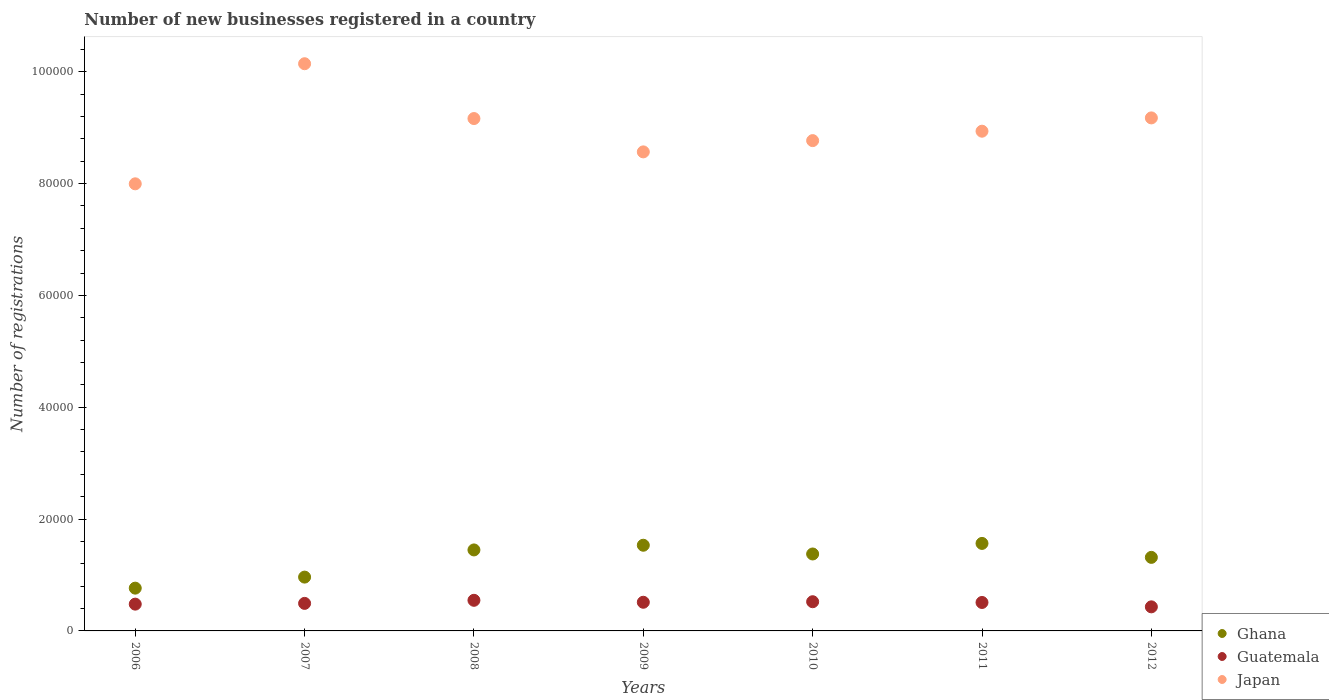What is the number of new businesses registered in Japan in 2010?
Your answer should be compact. 8.77e+04. Across all years, what is the maximum number of new businesses registered in Guatemala?
Ensure brevity in your answer.  5476. Across all years, what is the minimum number of new businesses registered in Guatemala?
Your response must be concise. 4306. In which year was the number of new businesses registered in Ghana maximum?
Ensure brevity in your answer.  2011. In which year was the number of new businesses registered in Guatemala minimum?
Give a very brief answer. 2012. What is the total number of new businesses registered in Guatemala in the graph?
Ensure brevity in your answer.  3.49e+04. What is the difference between the number of new businesses registered in Ghana in 2009 and that in 2012?
Your answer should be very brief. 2170. What is the difference between the number of new businesses registered in Ghana in 2011 and the number of new businesses registered in Japan in 2007?
Offer a terse response. -8.58e+04. What is the average number of new businesses registered in Japan per year?
Keep it short and to the point. 8.96e+04. In the year 2008, what is the difference between the number of new businesses registered in Guatemala and number of new businesses registered in Japan?
Your response must be concise. -8.62e+04. What is the ratio of the number of new businesses registered in Japan in 2008 to that in 2012?
Keep it short and to the point. 1. What is the difference between the highest and the second highest number of new businesses registered in Guatemala?
Your response must be concise. 254. What is the difference between the highest and the lowest number of new businesses registered in Ghana?
Offer a terse response. 7998. Is the sum of the number of new businesses registered in Ghana in 2009 and 2010 greater than the maximum number of new businesses registered in Japan across all years?
Provide a succinct answer. No. Is it the case that in every year, the sum of the number of new businesses registered in Guatemala and number of new businesses registered in Japan  is greater than the number of new businesses registered in Ghana?
Your answer should be compact. Yes. Does the number of new businesses registered in Ghana monotonically increase over the years?
Keep it short and to the point. No. Is the number of new businesses registered in Japan strictly greater than the number of new businesses registered in Ghana over the years?
Give a very brief answer. Yes. How many dotlines are there?
Make the answer very short. 3. What is the difference between two consecutive major ticks on the Y-axis?
Offer a very short reply. 2.00e+04. Where does the legend appear in the graph?
Keep it short and to the point. Bottom right. How many legend labels are there?
Provide a short and direct response. 3. What is the title of the graph?
Give a very brief answer. Number of new businesses registered in a country. What is the label or title of the Y-axis?
Offer a very short reply. Number of registrations. What is the Number of registrations in Ghana in 2006?
Your response must be concise. 7651. What is the Number of registrations in Guatemala in 2006?
Offer a very short reply. 4790. What is the Number of registrations of Japan in 2006?
Your answer should be very brief. 8.00e+04. What is the Number of registrations in Ghana in 2007?
Give a very brief answer. 9624. What is the Number of registrations of Guatemala in 2007?
Keep it short and to the point. 4925. What is the Number of registrations of Japan in 2007?
Offer a very short reply. 1.01e+05. What is the Number of registrations of Ghana in 2008?
Your answer should be very brief. 1.45e+04. What is the Number of registrations of Guatemala in 2008?
Provide a short and direct response. 5476. What is the Number of registrations of Japan in 2008?
Give a very brief answer. 9.16e+04. What is the Number of registrations of Ghana in 2009?
Provide a short and direct response. 1.53e+04. What is the Number of registrations of Guatemala in 2009?
Ensure brevity in your answer.  5126. What is the Number of registrations in Japan in 2009?
Your response must be concise. 8.57e+04. What is the Number of registrations in Ghana in 2010?
Provide a short and direct response. 1.38e+04. What is the Number of registrations in Guatemala in 2010?
Give a very brief answer. 5222. What is the Number of registrations of Japan in 2010?
Offer a very short reply. 8.77e+04. What is the Number of registrations of Ghana in 2011?
Keep it short and to the point. 1.56e+04. What is the Number of registrations of Guatemala in 2011?
Provide a succinct answer. 5088. What is the Number of registrations of Japan in 2011?
Give a very brief answer. 8.94e+04. What is the Number of registrations of Ghana in 2012?
Your response must be concise. 1.32e+04. What is the Number of registrations in Guatemala in 2012?
Your answer should be compact. 4306. What is the Number of registrations of Japan in 2012?
Offer a terse response. 9.18e+04. Across all years, what is the maximum Number of registrations of Ghana?
Offer a very short reply. 1.56e+04. Across all years, what is the maximum Number of registrations of Guatemala?
Offer a very short reply. 5476. Across all years, what is the maximum Number of registrations in Japan?
Keep it short and to the point. 1.01e+05. Across all years, what is the minimum Number of registrations in Ghana?
Provide a succinct answer. 7651. Across all years, what is the minimum Number of registrations of Guatemala?
Keep it short and to the point. 4306. Across all years, what is the minimum Number of registrations in Japan?
Provide a succinct answer. 8.00e+04. What is the total Number of registrations of Ghana in the graph?
Your answer should be very brief. 8.96e+04. What is the total Number of registrations of Guatemala in the graph?
Give a very brief answer. 3.49e+04. What is the total Number of registrations in Japan in the graph?
Keep it short and to the point. 6.28e+05. What is the difference between the Number of registrations in Ghana in 2006 and that in 2007?
Your answer should be very brief. -1973. What is the difference between the Number of registrations in Guatemala in 2006 and that in 2007?
Offer a very short reply. -135. What is the difference between the Number of registrations in Japan in 2006 and that in 2007?
Your response must be concise. -2.15e+04. What is the difference between the Number of registrations in Ghana in 2006 and that in 2008?
Ensure brevity in your answer.  -6834. What is the difference between the Number of registrations in Guatemala in 2006 and that in 2008?
Offer a terse response. -686. What is the difference between the Number of registrations in Japan in 2006 and that in 2008?
Offer a very short reply. -1.17e+04. What is the difference between the Number of registrations in Ghana in 2006 and that in 2009?
Ensure brevity in your answer.  -7673. What is the difference between the Number of registrations of Guatemala in 2006 and that in 2009?
Offer a terse response. -336. What is the difference between the Number of registrations of Japan in 2006 and that in 2009?
Your answer should be very brief. -5711. What is the difference between the Number of registrations of Ghana in 2006 and that in 2010?
Your response must be concise. -6109. What is the difference between the Number of registrations of Guatemala in 2006 and that in 2010?
Ensure brevity in your answer.  -432. What is the difference between the Number of registrations in Japan in 2006 and that in 2010?
Offer a very short reply. -7726. What is the difference between the Number of registrations of Ghana in 2006 and that in 2011?
Your answer should be very brief. -7998. What is the difference between the Number of registrations in Guatemala in 2006 and that in 2011?
Give a very brief answer. -298. What is the difference between the Number of registrations of Japan in 2006 and that in 2011?
Your answer should be compact. -9411. What is the difference between the Number of registrations of Ghana in 2006 and that in 2012?
Provide a short and direct response. -5503. What is the difference between the Number of registrations of Guatemala in 2006 and that in 2012?
Ensure brevity in your answer.  484. What is the difference between the Number of registrations of Japan in 2006 and that in 2012?
Provide a succinct answer. -1.18e+04. What is the difference between the Number of registrations of Ghana in 2007 and that in 2008?
Ensure brevity in your answer.  -4861. What is the difference between the Number of registrations in Guatemala in 2007 and that in 2008?
Provide a succinct answer. -551. What is the difference between the Number of registrations of Japan in 2007 and that in 2008?
Offer a very short reply. 9804. What is the difference between the Number of registrations in Ghana in 2007 and that in 2009?
Provide a succinct answer. -5700. What is the difference between the Number of registrations in Guatemala in 2007 and that in 2009?
Make the answer very short. -201. What is the difference between the Number of registrations of Japan in 2007 and that in 2009?
Offer a very short reply. 1.58e+04. What is the difference between the Number of registrations in Ghana in 2007 and that in 2010?
Your answer should be very brief. -4136. What is the difference between the Number of registrations in Guatemala in 2007 and that in 2010?
Offer a terse response. -297. What is the difference between the Number of registrations of Japan in 2007 and that in 2010?
Provide a succinct answer. 1.38e+04. What is the difference between the Number of registrations in Ghana in 2007 and that in 2011?
Offer a very short reply. -6025. What is the difference between the Number of registrations in Guatemala in 2007 and that in 2011?
Offer a terse response. -163. What is the difference between the Number of registrations of Japan in 2007 and that in 2011?
Ensure brevity in your answer.  1.21e+04. What is the difference between the Number of registrations of Ghana in 2007 and that in 2012?
Offer a very short reply. -3530. What is the difference between the Number of registrations in Guatemala in 2007 and that in 2012?
Keep it short and to the point. 619. What is the difference between the Number of registrations in Japan in 2007 and that in 2012?
Your response must be concise. 9688. What is the difference between the Number of registrations in Ghana in 2008 and that in 2009?
Offer a terse response. -839. What is the difference between the Number of registrations in Guatemala in 2008 and that in 2009?
Provide a short and direct response. 350. What is the difference between the Number of registrations of Japan in 2008 and that in 2009?
Give a very brief answer. 5962. What is the difference between the Number of registrations in Ghana in 2008 and that in 2010?
Keep it short and to the point. 725. What is the difference between the Number of registrations in Guatemala in 2008 and that in 2010?
Make the answer very short. 254. What is the difference between the Number of registrations in Japan in 2008 and that in 2010?
Your answer should be very brief. 3947. What is the difference between the Number of registrations in Ghana in 2008 and that in 2011?
Your response must be concise. -1164. What is the difference between the Number of registrations in Guatemala in 2008 and that in 2011?
Offer a terse response. 388. What is the difference between the Number of registrations in Japan in 2008 and that in 2011?
Offer a very short reply. 2262. What is the difference between the Number of registrations in Ghana in 2008 and that in 2012?
Offer a very short reply. 1331. What is the difference between the Number of registrations of Guatemala in 2008 and that in 2012?
Ensure brevity in your answer.  1170. What is the difference between the Number of registrations in Japan in 2008 and that in 2012?
Offer a terse response. -116. What is the difference between the Number of registrations in Ghana in 2009 and that in 2010?
Make the answer very short. 1564. What is the difference between the Number of registrations of Guatemala in 2009 and that in 2010?
Your response must be concise. -96. What is the difference between the Number of registrations of Japan in 2009 and that in 2010?
Make the answer very short. -2015. What is the difference between the Number of registrations in Ghana in 2009 and that in 2011?
Offer a very short reply. -325. What is the difference between the Number of registrations of Japan in 2009 and that in 2011?
Ensure brevity in your answer.  -3700. What is the difference between the Number of registrations of Ghana in 2009 and that in 2012?
Offer a very short reply. 2170. What is the difference between the Number of registrations in Guatemala in 2009 and that in 2012?
Keep it short and to the point. 820. What is the difference between the Number of registrations in Japan in 2009 and that in 2012?
Provide a short and direct response. -6078. What is the difference between the Number of registrations in Ghana in 2010 and that in 2011?
Your response must be concise. -1889. What is the difference between the Number of registrations of Guatemala in 2010 and that in 2011?
Your response must be concise. 134. What is the difference between the Number of registrations of Japan in 2010 and that in 2011?
Provide a short and direct response. -1685. What is the difference between the Number of registrations in Ghana in 2010 and that in 2012?
Your answer should be compact. 606. What is the difference between the Number of registrations of Guatemala in 2010 and that in 2012?
Provide a succinct answer. 916. What is the difference between the Number of registrations of Japan in 2010 and that in 2012?
Provide a succinct answer. -4063. What is the difference between the Number of registrations of Ghana in 2011 and that in 2012?
Keep it short and to the point. 2495. What is the difference between the Number of registrations of Guatemala in 2011 and that in 2012?
Give a very brief answer. 782. What is the difference between the Number of registrations of Japan in 2011 and that in 2012?
Ensure brevity in your answer.  -2378. What is the difference between the Number of registrations in Ghana in 2006 and the Number of registrations in Guatemala in 2007?
Provide a short and direct response. 2726. What is the difference between the Number of registrations in Ghana in 2006 and the Number of registrations in Japan in 2007?
Offer a terse response. -9.38e+04. What is the difference between the Number of registrations of Guatemala in 2006 and the Number of registrations of Japan in 2007?
Make the answer very short. -9.66e+04. What is the difference between the Number of registrations in Ghana in 2006 and the Number of registrations in Guatemala in 2008?
Your answer should be very brief. 2175. What is the difference between the Number of registrations in Ghana in 2006 and the Number of registrations in Japan in 2008?
Provide a succinct answer. -8.40e+04. What is the difference between the Number of registrations in Guatemala in 2006 and the Number of registrations in Japan in 2008?
Ensure brevity in your answer.  -8.68e+04. What is the difference between the Number of registrations in Ghana in 2006 and the Number of registrations in Guatemala in 2009?
Ensure brevity in your answer.  2525. What is the difference between the Number of registrations in Ghana in 2006 and the Number of registrations in Japan in 2009?
Your answer should be very brief. -7.80e+04. What is the difference between the Number of registrations in Guatemala in 2006 and the Number of registrations in Japan in 2009?
Make the answer very short. -8.09e+04. What is the difference between the Number of registrations of Ghana in 2006 and the Number of registrations of Guatemala in 2010?
Make the answer very short. 2429. What is the difference between the Number of registrations in Ghana in 2006 and the Number of registrations in Japan in 2010?
Your answer should be compact. -8.00e+04. What is the difference between the Number of registrations in Guatemala in 2006 and the Number of registrations in Japan in 2010?
Keep it short and to the point. -8.29e+04. What is the difference between the Number of registrations of Ghana in 2006 and the Number of registrations of Guatemala in 2011?
Offer a very short reply. 2563. What is the difference between the Number of registrations in Ghana in 2006 and the Number of registrations in Japan in 2011?
Provide a succinct answer. -8.17e+04. What is the difference between the Number of registrations of Guatemala in 2006 and the Number of registrations of Japan in 2011?
Ensure brevity in your answer.  -8.46e+04. What is the difference between the Number of registrations in Ghana in 2006 and the Number of registrations in Guatemala in 2012?
Keep it short and to the point. 3345. What is the difference between the Number of registrations in Ghana in 2006 and the Number of registrations in Japan in 2012?
Your answer should be very brief. -8.41e+04. What is the difference between the Number of registrations of Guatemala in 2006 and the Number of registrations of Japan in 2012?
Keep it short and to the point. -8.70e+04. What is the difference between the Number of registrations of Ghana in 2007 and the Number of registrations of Guatemala in 2008?
Your answer should be very brief. 4148. What is the difference between the Number of registrations of Ghana in 2007 and the Number of registrations of Japan in 2008?
Provide a short and direct response. -8.20e+04. What is the difference between the Number of registrations in Guatemala in 2007 and the Number of registrations in Japan in 2008?
Your response must be concise. -8.67e+04. What is the difference between the Number of registrations in Ghana in 2007 and the Number of registrations in Guatemala in 2009?
Provide a succinct answer. 4498. What is the difference between the Number of registrations in Ghana in 2007 and the Number of registrations in Japan in 2009?
Offer a terse response. -7.60e+04. What is the difference between the Number of registrations of Guatemala in 2007 and the Number of registrations of Japan in 2009?
Make the answer very short. -8.07e+04. What is the difference between the Number of registrations in Ghana in 2007 and the Number of registrations in Guatemala in 2010?
Keep it short and to the point. 4402. What is the difference between the Number of registrations of Ghana in 2007 and the Number of registrations of Japan in 2010?
Your response must be concise. -7.81e+04. What is the difference between the Number of registrations in Guatemala in 2007 and the Number of registrations in Japan in 2010?
Your response must be concise. -8.28e+04. What is the difference between the Number of registrations in Ghana in 2007 and the Number of registrations in Guatemala in 2011?
Offer a very short reply. 4536. What is the difference between the Number of registrations of Ghana in 2007 and the Number of registrations of Japan in 2011?
Offer a terse response. -7.97e+04. What is the difference between the Number of registrations in Guatemala in 2007 and the Number of registrations in Japan in 2011?
Provide a short and direct response. -8.44e+04. What is the difference between the Number of registrations in Ghana in 2007 and the Number of registrations in Guatemala in 2012?
Provide a short and direct response. 5318. What is the difference between the Number of registrations in Ghana in 2007 and the Number of registrations in Japan in 2012?
Provide a short and direct response. -8.21e+04. What is the difference between the Number of registrations in Guatemala in 2007 and the Number of registrations in Japan in 2012?
Offer a terse response. -8.68e+04. What is the difference between the Number of registrations in Ghana in 2008 and the Number of registrations in Guatemala in 2009?
Your answer should be compact. 9359. What is the difference between the Number of registrations of Ghana in 2008 and the Number of registrations of Japan in 2009?
Provide a short and direct response. -7.12e+04. What is the difference between the Number of registrations of Guatemala in 2008 and the Number of registrations of Japan in 2009?
Make the answer very short. -8.02e+04. What is the difference between the Number of registrations in Ghana in 2008 and the Number of registrations in Guatemala in 2010?
Provide a short and direct response. 9263. What is the difference between the Number of registrations of Ghana in 2008 and the Number of registrations of Japan in 2010?
Your answer should be compact. -7.32e+04. What is the difference between the Number of registrations in Guatemala in 2008 and the Number of registrations in Japan in 2010?
Make the answer very short. -8.22e+04. What is the difference between the Number of registrations of Ghana in 2008 and the Number of registrations of Guatemala in 2011?
Your response must be concise. 9397. What is the difference between the Number of registrations of Ghana in 2008 and the Number of registrations of Japan in 2011?
Ensure brevity in your answer.  -7.49e+04. What is the difference between the Number of registrations of Guatemala in 2008 and the Number of registrations of Japan in 2011?
Keep it short and to the point. -8.39e+04. What is the difference between the Number of registrations of Ghana in 2008 and the Number of registrations of Guatemala in 2012?
Offer a very short reply. 1.02e+04. What is the difference between the Number of registrations in Ghana in 2008 and the Number of registrations in Japan in 2012?
Offer a terse response. -7.73e+04. What is the difference between the Number of registrations of Guatemala in 2008 and the Number of registrations of Japan in 2012?
Your response must be concise. -8.63e+04. What is the difference between the Number of registrations of Ghana in 2009 and the Number of registrations of Guatemala in 2010?
Your answer should be compact. 1.01e+04. What is the difference between the Number of registrations in Ghana in 2009 and the Number of registrations in Japan in 2010?
Offer a very short reply. -7.24e+04. What is the difference between the Number of registrations of Guatemala in 2009 and the Number of registrations of Japan in 2010?
Your response must be concise. -8.26e+04. What is the difference between the Number of registrations in Ghana in 2009 and the Number of registrations in Guatemala in 2011?
Make the answer very short. 1.02e+04. What is the difference between the Number of registrations of Ghana in 2009 and the Number of registrations of Japan in 2011?
Make the answer very short. -7.40e+04. What is the difference between the Number of registrations in Guatemala in 2009 and the Number of registrations in Japan in 2011?
Your answer should be compact. -8.42e+04. What is the difference between the Number of registrations of Ghana in 2009 and the Number of registrations of Guatemala in 2012?
Keep it short and to the point. 1.10e+04. What is the difference between the Number of registrations of Ghana in 2009 and the Number of registrations of Japan in 2012?
Keep it short and to the point. -7.64e+04. What is the difference between the Number of registrations in Guatemala in 2009 and the Number of registrations in Japan in 2012?
Make the answer very short. -8.66e+04. What is the difference between the Number of registrations of Ghana in 2010 and the Number of registrations of Guatemala in 2011?
Your answer should be very brief. 8672. What is the difference between the Number of registrations in Ghana in 2010 and the Number of registrations in Japan in 2011?
Keep it short and to the point. -7.56e+04. What is the difference between the Number of registrations of Guatemala in 2010 and the Number of registrations of Japan in 2011?
Provide a succinct answer. -8.42e+04. What is the difference between the Number of registrations in Ghana in 2010 and the Number of registrations in Guatemala in 2012?
Ensure brevity in your answer.  9454. What is the difference between the Number of registrations in Ghana in 2010 and the Number of registrations in Japan in 2012?
Offer a terse response. -7.80e+04. What is the difference between the Number of registrations in Guatemala in 2010 and the Number of registrations in Japan in 2012?
Your answer should be very brief. -8.65e+04. What is the difference between the Number of registrations in Ghana in 2011 and the Number of registrations in Guatemala in 2012?
Offer a very short reply. 1.13e+04. What is the difference between the Number of registrations in Ghana in 2011 and the Number of registrations in Japan in 2012?
Your answer should be very brief. -7.61e+04. What is the difference between the Number of registrations in Guatemala in 2011 and the Number of registrations in Japan in 2012?
Provide a short and direct response. -8.67e+04. What is the average Number of registrations in Ghana per year?
Ensure brevity in your answer.  1.28e+04. What is the average Number of registrations of Guatemala per year?
Give a very brief answer. 4990.43. What is the average Number of registrations of Japan per year?
Keep it short and to the point. 8.96e+04. In the year 2006, what is the difference between the Number of registrations of Ghana and Number of registrations of Guatemala?
Provide a succinct answer. 2861. In the year 2006, what is the difference between the Number of registrations in Ghana and Number of registrations in Japan?
Offer a very short reply. -7.23e+04. In the year 2006, what is the difference between the Number of registrations of Guatemala and Number of registrations of Japan?
Your response must be concise. -7.52e+04. In the year 2007, what is the difference between the Number of registrations of Ghana and Number of registrations of Guatemala?
Provide a short and direct response. 4699. In the year 2007, what is the difference between the Number of registrations in Ghana and Number of registrations in Japan?
Your answer should be very brief. -9.18e+04. In the year 2007, what is the difference between the Number of registrations in Guatemala and Number of registrations in Japan?
Your response must be concise. -9.65e+04. In the year 2008, what is the difference between the Number of registrations of Ghana and Number of registrations of Guatemala?
Ensure brevity in your answer.  9009. In the year 2008, what is the difference between the Number of registrations in Ghana and Number of registrations in Japan?
Give a very brief answer. -7.72e+04. In the year 2008, what is the difference between the Number of registrations of Guatemala and Number of registrations of Japan?
Offer a terse response. -8.62e+04. In the year 2009, what is the difference between the Number of registrations in Ghana and Number of registrations in Guatemala?
Your answer should be very brief. 1.02e+04. In the year 2009, what is the difference between the Number of registrations in Ghana and Number of registrations in Japan?
Your answer should be compact. -7.03e+04. In the year 2009, what is the difference between the Number of registrations of Guatemala and Number of registrations of Japan?
Your response must be concise. -8.05e+04. In the year 2010, what is the difference between the Number of registrations in Ghana and Number of registrations in Guatemala?
Ensure brevity in your answer.  8538. In the year 2010, what is the difference between the Number of registrations of Ghana and Number of registrations of Japan?
Offer a terse response. -7.39e+04. In the year 2010, what is the difference between the Number of registrations of Guatemala and Number of registrations of Japan?
Your answer should be very brief. -8.25e+04. In the year 2011, what is the difference between the Number of registrations of Ghana and Number of registrations of Guatemala?
Give a very brief answer. 1.06e+04. In the year 2011, what is the difference between the Number of registrations of Ghana and Number of registrations of Japan?
Make the answer very short. -7.37e+04. In the year 2011, what is the difference between the Number of registrations in Guatemala and Number of registrations in Japan?
Provide a short and direct response. -8.43e+04. In the year 2012, what is the difference between the Number of registrations of Ghana and Number of registrations of Guatemala?
Ensure brevity in your answer.  8848. In the year 2012, what is the difference between the Number of registrations of Ghana and Number of registrations of Japan?
Provide a short and direct response. -7.86e+04. In the year 2012, what is the difference between the Number of registrations of Guatemala and Number of registrations of Japan?
Give a very brief answer. -8.74e+04. What is the ratio of the Number of registrations of Ghana in 2006 to that in 2007?
Your answer should be compact. 0.8. What is the ratio of the Number of registrations in Guatemala in 2006 to that in 2007?
Provide a short and direct response. 0.97. What is the ratio of the Number of registrations in Japan in 2006 to that in 2007?
Your answer should be compact. 0.79. What is the ratio of the Number of registrations of Ghana in 2006 to that in 2008?
Provide a succinct answer. 0.53. What is the ratio of the Number of registrations of Guatemala in 2006 to that in 2008?
Provide a short and direct response. 0.87. What is the ratio of the Number of registrations in Japan in 2006 to that in 2008?
Ensure brevity in your answer.  0.87. What is the ratio of the Number of registrations of Ghana in 2006 to that in 2009?
Ensure brevity in your answer.  0.5. What is the ratio of the Number of registrations in Guatemala in 2006 to that in 2009?
Keep it short and to the point. 0.93. What is the ratio of the Number of registrations in Japan in 2006 to that in 2009?
Make the answer very short. 0.93. What is the ratio of the Number of registrations of Ghana in 2006 to that in 2010?
Ensure brevity in your answer.  0.56. What is the ratio of the Number of registrations in Guatemala in 2006 to that in 2010?
Your answer should be very brief. 0.92. What is the ratio of the Number of registrations in Japan in 2006 to that in 2010?
Your answer should be very brief. 0.91. What is the ratio of the Number of registrations in Ghana in 2006 to that in 2011?
Give a very brief answer. 0.49. What is the ratio of the Number of registrations of Guatemala in 2006 to that in 2011?
Ensure brevity in your answer.  0.94. What is the ratio of the Number of registrations in Japan in 2006 to that in 2011?
Your answer should be very brief. 0.89. What is the ratio of the Number of registrations of Ghana in 2006 to that in 2012?
Offer a terse response. 0.58. What is the ratio of the Number of registrations of Guatemala in 2006 to that in 2012?
Your answer should be compact. 1.11. What is the ratio of the Number of registrations of Japan in 2006 to that in 2012?
Your response must be concise. 0.87. What is the ratio of the Number of registrations in Ghana in 2007 to that in 2008?
Provide a succinct answer. 0.66. What is the ratio of the Number of registrations in Guatemala in 2007 to that in 2008?
Provide a succinct answer. 0.9. What is the ratio of the Number of registrations in Japan in 2007 to that in 2008?
Your answer should be compact. 1.11. What is the ratio of the Number of registrations in Ghana in 2007 to that in 2009?
Ensure brevity in your answer.  0.63. What is the ratio of the Number of registrations of Guatemala in 2007 to that in 2009?
Your answer should be very brief. 0.96. What is the ratio of the Number of registrations of Japan in 2007 to that in 2009?
Your answer should be very brief. 1.18. What is the ratio of the Number of registrations in Ghana in 2007 to that in 2010?
Your answer should be compact. 0.7. What is the ratio of the Number of registrations of Guatemala in 2007 to that in 2010?
Provide a short and direct response. 0.94. What is the ratio of the Number of registrations in Japan in 2007 to that in 2010?
Provide a short and direct response. 1.16. What is the ratio of the Number of registrations in Ghana in 2007 to that in 2011?
Your answer should be compact. 0.61. What is the ratio of the Number of registrations in Japan in 2007 to that in 2011?
Your answer should be compact. 1.14. What is the ratio of the Number of registrations in Ghana in 2007 to that in 2012?
Provide a succinct answer. 0.73. What is the ratio of the Number of registrations in Guatemala in 2007 to that in 2012?
Your answer should be compact. 1.14. What is the ratio of the Number of registrations in Japan in 2007 to that in 2012?
Your answer should be very brief. 1.11. What is the ratio of the Number of registrations of Ghana in 2008 to that in 2009?
Give a very brief answer. 0.95. What is the ratio of the Number of registrations of Guatemala in 2008 to that in 2009?
Keep it short and to the point. 1.07. What is the ratio of the Number of registrations in Japan in 2008 to that in 2009?
Keep it short and to the point. 1.07. What is the ratio of the Number of registrations in Ghana in 2008 to that in 2010?
Keep it short and to the point. 1.05. What is the ratio of the Number of registrations of Guatemala in 2008 to that in 2010?
Your response must be concise. 1.05. What is the ratio of the Number of registrations in Japan in 2008 to that in 2010?
Give a very brief answer. 1.04. What is the ratio of the Number of registrations in Ghana in 2008 to that in 2011?
Keep it short and to the point. 0.93. What is the ratio of the Number of registrations in Guatemala in 2008 to that in 2011?
Offer a terse response. 1.08. What is the ratio of the Number of registrations of Japan in 2008 to that in 2011?
Offer a terse response. 1.03. What is the ratio of the Number of registrations in Ghana in 2008 to that in 2012?
Your answer should be compact. 1.1. What is the ratio of the Number of registrations in Guatemala in 2008 to that in 2012?
Give a very brief answer. 1.27. What is the ratio of the Number of registrations in Japan in 2008 to that in 2012?
Your answer should be very brief. 1. What is the ratio of the Number of registrations in Ghana in 2009 to that in 2010?
Keep it short and to the point. 1.11. What is the ratio of the Number of registrations in Guatemala in 2009 to that in 2010?
Offer a terse response. 0.98. What is the ratio of the Number of registrations of Ghana in 2009 to that in 2011?
Ensure brevity in your answer.  0.98. What is the ratio of the Number of registrations of Guatemala in 2009 to that in 2011?
Your answer should be very brief. 1.01. What is the ratio of the Number of registrations of Japan in 2009 to that in 2011?
Give a very brief answer. 0.96. What is the ratio of the Number of registrations of Ghana in 2009 to that in 2012?
Provide a short and direct response. 1.17. What is the ratio of the Number of registrations of Guatemala in 2009 to that in 2012?
Your answer should be very brief. 1.19. What is the ratio of the Number of registrations in Japan in 2009 to that in 2012?
Offer a terse response. 0.93. What is the ratio of the Number of registrations of Ghana in 2010 to that in 2011?
Provide a short and direct response. 0.88. What is the ratio of the Number of registrations in Guatemala in 2010 to that in 2011?
Offer a terse response. 1.03. What is the ratio of the Number of registrations of Japan in 2010 to that in 2011?
Keep it short and to the point. 0.98. What is the ratio of the Number of registrations in Ghana in 2010 to that in 2012?
Keep it short and to the point. 1.05. What is the ratio of the Number of registrations in Guatemala in 2010 to that in 2012?
Your answer should be compact. 1.21. What is the ratio of the Number of registrations of Japan in 2010 to that in 2012?
Your answer should be very brief. 0.96. What is the ratio of the Number of registrations of Ghana in 2011 to that in 2012?
Your response must be concise. 1.19. What is the ratio of the Number of registrations of Guatemala in 2011 to that in 2012?
Ensure brevity in your answer.  1.18. What is the ratio of the Number of registrations in Japan in 2011 to that in 2012?
Your answer should be very brief. 0.97. What is the difference between the highest and the second highest Number of registrations in Ghana?
Ensure brevity in your answer.  325. What is the difference between the highest and the second highest Number of registrations in Guatemala?
Your answer should be compact. 254. What is the difference between the highest and the second highest Number of registrations in Japan?
Provide a succinct answer. 9688. What is the difference between the highest and the lowest Number of registrations in Ghana?
Make the answer very short. 7998. What is the difference between the highest and the lowest Number of registrations in Guatemala?
Offer a terse response. 1170. What is the difference between the highest and the lowest Number of registrations of Japan?
Provide a short and direct response. 2.15e+04. 